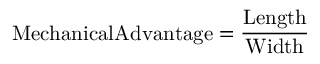Convert formula to latex. <formula><loc_0><loc_0><loc_500><loc_500>{ M e c h a n i c a l A d v a n t a g e = { \frac { L e n g t h } { W i d t h } } }</formula> 